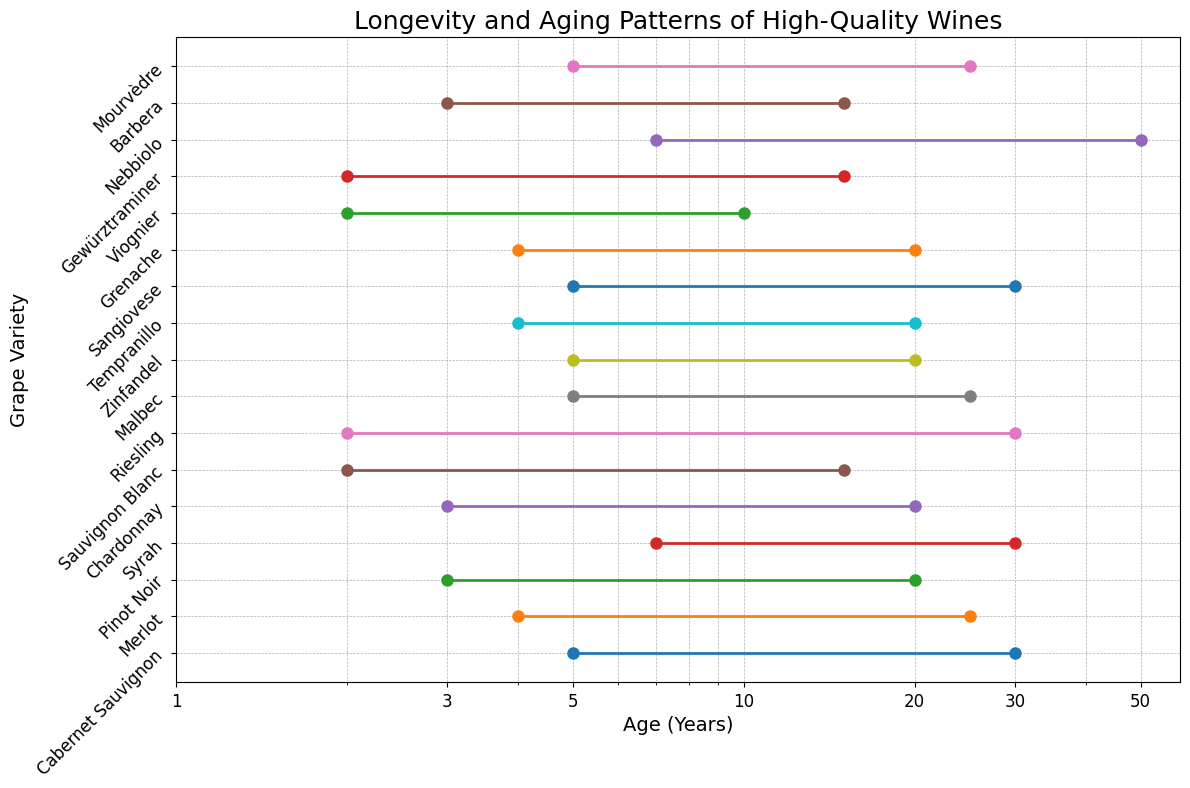What is the grape variety that has the longest maximum aging potential? Nebbiolo has the longest maximum age of 50 years compared to other grape varieties.
Answer: Nebbiolo Which grape varieties have the same maximum aging potential of 30 years? Cabernet Sauvignon, Syrah, Riesling, and Sangiovese all have a maximum aging potential of 30 years.
Answer: Cabernet Sauvignon, Syrah, Riesling, Sangiovese What is the minimum age range (in years) for all grape varieties combined? The minimum age for all grape varieties ranges from 2 to 7 years, with the smallest minimum age being 2 years for Sauvignon Blanc, Riesling, Viognier, and Gewürztraminer, and the largest minimum age being 7 years for Syrah and Nebbiolo. The range is 7 - 2 = 5 years.
Answer: 5 years What is the difference between the maximum aging potential of Chardonnay and Nebbiolo? Nebbiolo has a maximum aging potential of 50 years, while Chardonnay has a maximum aging potential of 20 years. The difference is 50 - 20 = 30 years.
Answer: 30 years Which grape varieties have a minimum aging potential of less than 5 years? Sauvignon Blanc, Riesling, Chardonnay, Viognier, and Gewürztraminer all have a minimum aging potential of less than 5 years.
Answer: Sauvignon Blanc, Riesling, Chardonnay, Viognier, Gewürztraminer Which grape variety has the closest maximum aging potential to Zinfandel? Zinfandel has a maximum aging potential of 20 years, and the closest maximum aging potential is for Chardonnay, Pinot Noir, Tempranillo, and Grenache, which are also 20 years.
Answer: Chardonnay, Pinot Noir, Tempranillo, Grenache What is the average maximum aging potential for all grape varieties combined? Sum all maximum aging potentials: 30 + 25 + 20 + 30 + 20 + 15 + 30 + 25 + 20 + 20 + 30 + 20 + 10 + 15 + 50 + 15 + 25 = 400. There are 17 grape varieties, so the average is 400 / 17 ≈ 23.53 years.
Answer: 23.53 years Which grape variety has the widest aging range? The aging range is the difference between the maximum and minimum ages. Nebbiolo has the widest range of 50 - 7 = 43 years.
Answer: Nebbiolo How many grape varieties have a maximum aging potential of at least 30 years? The grape varieties with a maximum aging potential of 30 years or more are Cabernet Sauvignon, Syrah, Riesling, Sangiovese, and Nebbiolo, which makes 5 varieties.
Answer: 5 grape varieties 